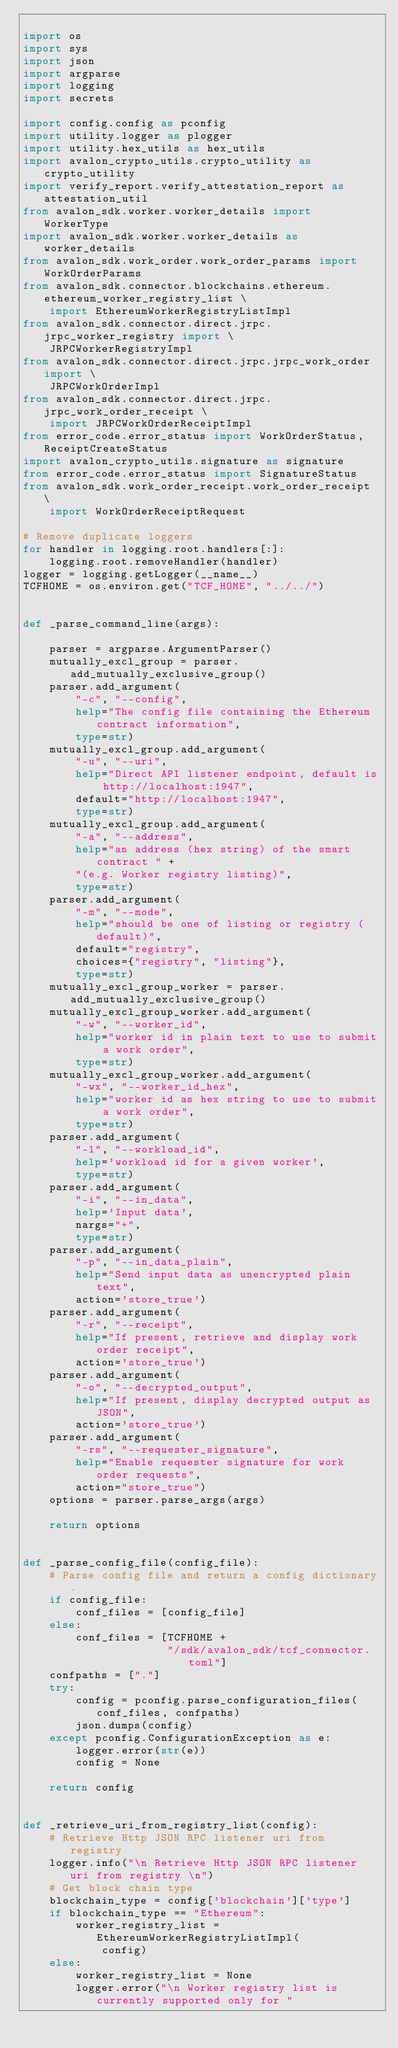Convert code to text. <code><loc_0><loc_0><loc_500><loc_500><_Python_>
import os
import sys
import json
import argparse
import logging
import secrets

import config.config as pconfig
import utility.logger as plogger
import utility.hex_utils as hex_utils
import avalon_crypto_utils.crypto_utility as crypto_utility
import verify_report.verify_attestation_report as attestation_util
from avalon_sdk.worker.worker_details import WorkerType
import avalon_sdk.worker.worker_details as worker_details
from avalon_sdk.work_order.work_order_params import WorkOrderParams
from avalon_sdk.connector.blockchains.ethereum.ethereum_worker_registry_list \
    import EthereumWorkerRegistryListImpl
from avalon_sdk.connector.direct.jrpc.jrpc_worker_registry import \
    JRPCWorkerRegistryImpl
from avalon_sdk.connector.direct.jrpc.jrpc_work_order import \
    JRPCWorkOrderImpl
from avalon_sdk.connector.direct.jrpc.jrpc_work_order_receipt \
    import JRPCWorkOrderReceiptImpl
from error_code.error_status import WorkOrderStatus, ReceiptCreateStatus
import avalon_crypto_utils.signature as signature
from error_code.error_status import SignatureStatus
from avalon_sdk.work_order_receipt.work_order_receipt \
    import WorkOrderReceiptRequest

# Remove duplicate loggers
for handler in logging.root.handlers[:]:
    logging.root.removeHandler(handler)
logger = logging.getLogger(__name__)
TCFHOME = os.environ.get("TCF_HOME", "../../")


def _parse_command_line(args):

    parser = argparse.ArgumentParser()
    mutually_excl_group = parser.add_mutually_exclusive_group()
    parser.add_argument(
        "-c", "--config",
        help="The config file containing the Ethereum contract information",
        type=str)
    mutually_excl_group.add_argument(
        "-u", "--uri",
        help="Direct API listener endpoint, default is http://localhost:1947",
        default="http://localhost:1947",
        type=str)
    mutually_excl_group.add_argument(
        "-a", "--address",
        help="an address (hex string) of the smart contract " +
        "(e.g. Worker registry listing)",
        type=str)
    parser.add_argument(
        "-m", "--mode",
        help="should be one of listing or registry (default)",
        default="registry",
        choices={"registry", "listing"},
        type=str)
    mutually_excl_group_worker = parser.add_mutually_exclusive_group()
    mutually_excl_group_worker.add_argument(
        "-w", "--worker_id",
        help="worker id in plain text to use to submit a work order",
        type=str)
    mutually_excl_group_worker.add_argument(
        "-wx", "--worker_id_hex",
        help="worker id as hex string to use to submit a work order",
        type=str)
    parser.add_argument(
        "-l", "--workload_id",
        help='workload id for a given worker',
        type=str)
    parser.add_argument(
        "-i", "--in_data",
        help='Input data',
        nargs="+",
        type=str)
    parser.add_argument(
        "-p", "--in_data_plain",
        help="Send input data as unencrypted plain text",
        action='store_true')
    parser.add_argument(
        "-r", "--receipt",
        help="If present, retrieve and display work order receipt",
        action='store_true')
    parser.add_argument(
        "-o", "--decrypted_output",
        help="If present, display decrypted output as JSON",
        action='store_true')
    parser.add_argument(
        "-rs", "--requester_signature",
        help="Enable requester signature for work order requests",
        action="store_true")
    options = parser.parse_args(args)

    return options


def _parse_config_file(config_file):
    # Parse config file and return a config dictionary.
    if config_file:
        conf_files = [config_file]
    else:
        conf_files = [TCFHOME +
                      "/sdk/avalon_sdk/tcf_connector.toml"]
    confpaths = ["."]
    try:
        config = pconfig.parse_configuration_files(conf_files, confpaths)
        json.dumps(config)
    except pconfig.ConfigurationException as e:
        logger.error(str(e))
        config = None

    return config


def _retrieve_uri_from_registry_list(config):
    # Retrieve Http JSON RPC listener uri from registry
    logger.info("\n Retrieve Http JSON RPC listener uri from registry \n")
    # Get block chain type
    blockchain_type = config['blockchain']['type']
    if blockchain_type == "Ethereum":
        worker_registry_list = EthereumWorkerRegistryListImpl(
            config)
    else:
        worker_registry_list = None
        logger.error("\n Worker registry list is currently supported only for "</code> 